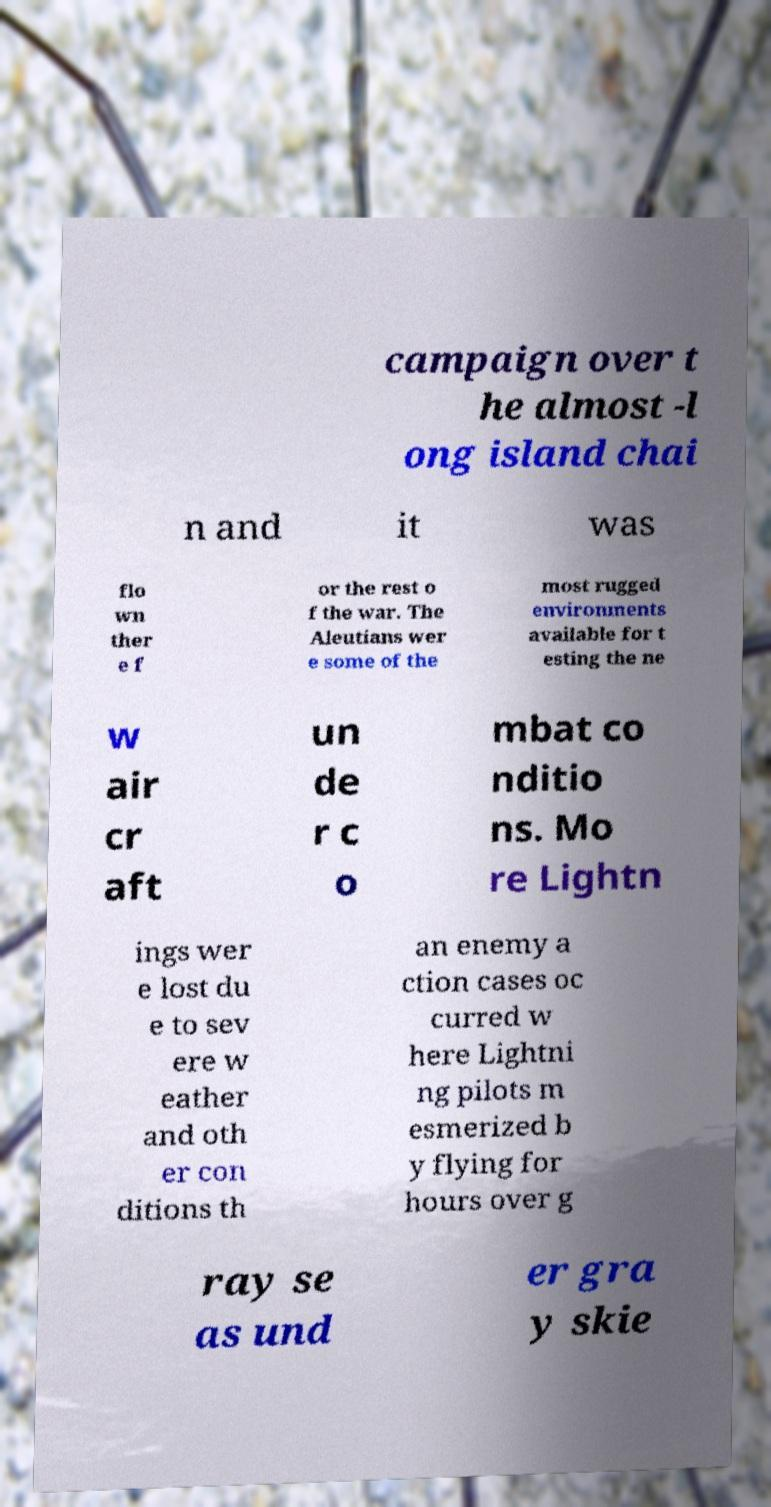Can you accurately transcribe the text from the provided image for me? campaign over t he almost -l ong island chai n and it was flo wn ther e f or the rest o f the war. The Aleutians wer e some of the most rugged environments available for t esting the ne w air cr aft un de r c o mbat co nditio ns. Mo re Lightn ings wer e lost du e to sev ere w eather and oth er con ditions th an enemy a ction cases oc curred w here Lightni ng pilots m esmerized b y flying for hours over g ray se as und er gra y skie 